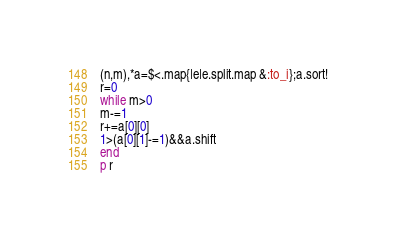<code> <loc_0><loc_0><loc_500><loc_500><_Ruby_>(n,m),*a=$<.map{|e|e.split.map &:to_i};a.sort!
r=0
while m>0
m-=1
r+=a[0][0]
1>(a[0][1]-=1)&&a.shift
end
p r</code> 